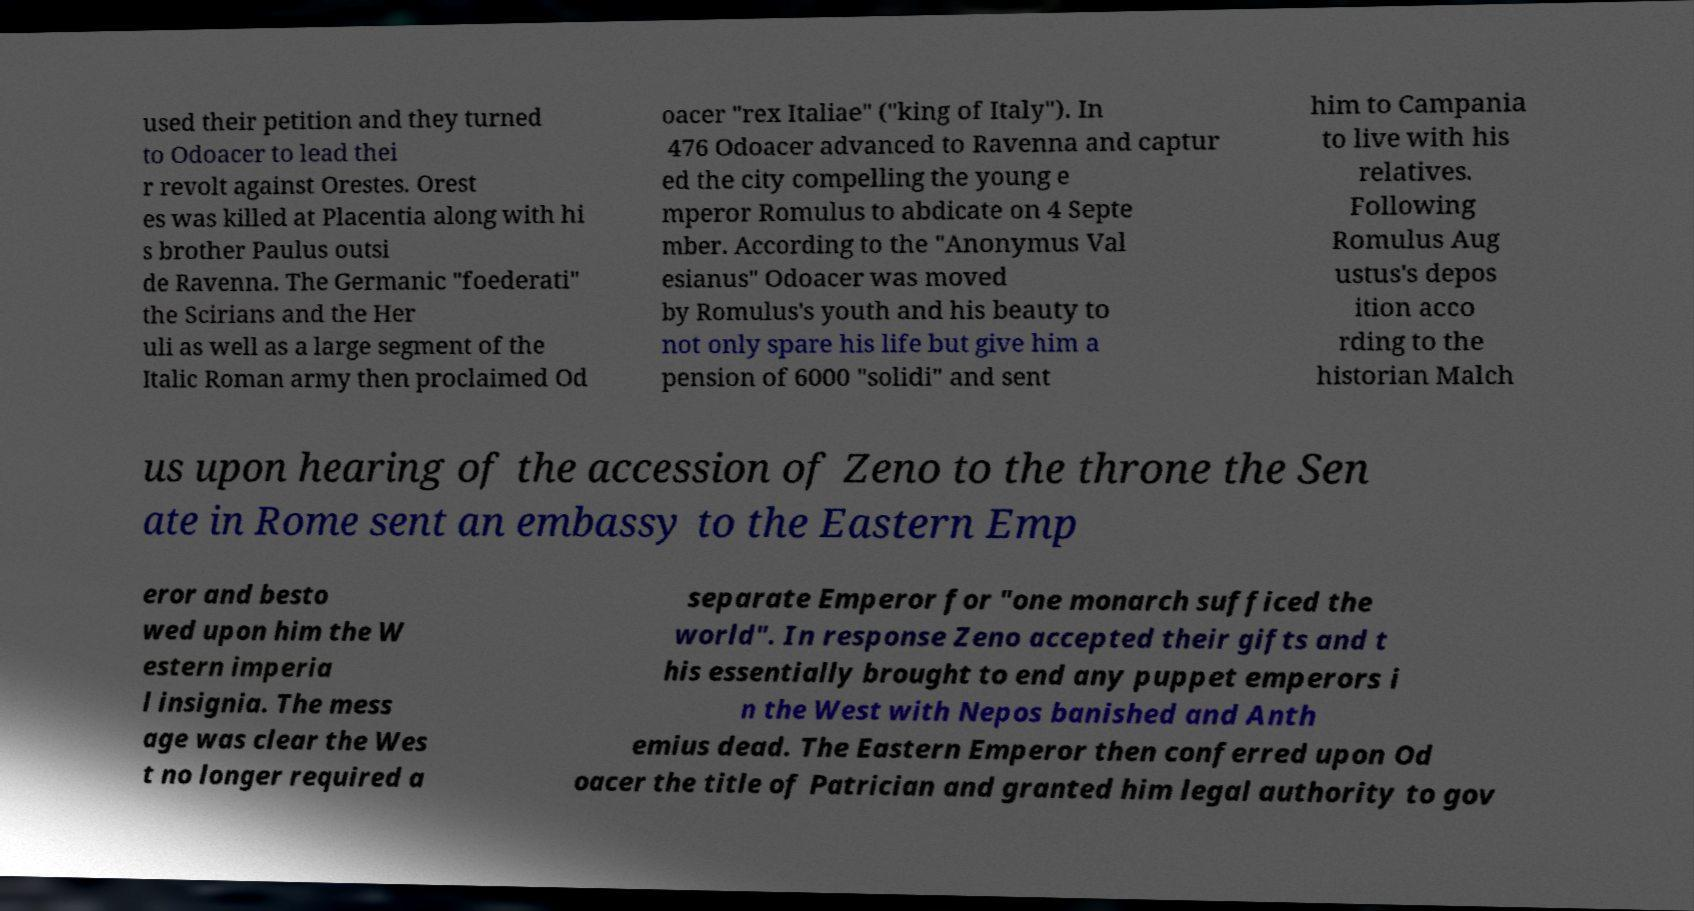Could you assist in decoding the text presented in this image and type it out clearly? used their petition and they turned to Odoacer to lead thei r revolt against Orestes. Orest es was killed at Placentia along with hi s brother Paulus outsi de Ravenna. The Germanic "foederati" the Scirians and the Her uli as well as a large segment of the Italic Roman army then proclaimed Od oacer "rex Italiae" ("king of Italy"). In 476 Odoacer advanced to Ravenna and captur ed the city compelling the young e mperor Romulus to abdicate on 4 Septe mber. According to the "Anonymus Val esianus" Odoacer was moved by Romulus's youth and his beauty to not only spare his life but give him a pension of 6000 "solidi" and sent him to Campania to live with his relatives. Following Romulus Aug ustus's depos ition acco rding to the historian Malch us upon hearing of the accession of Zeno to the throne the Sen ate in Rome sent an embassy to the Eastern Emp eror and besto wed upon him the W estern imperia l insignia. The mess age was clear the Wes t no longer required a separate Emperor for "one monarch sufficed the world". In response Zeno accepted their gifts and t his essentially brought to end any puppet emperors i n the West with Nepos banished and Anth emius dead. The Eastern Emperor then conferred upon Od oacer the title of Patrician and granted him legal authority to gov 